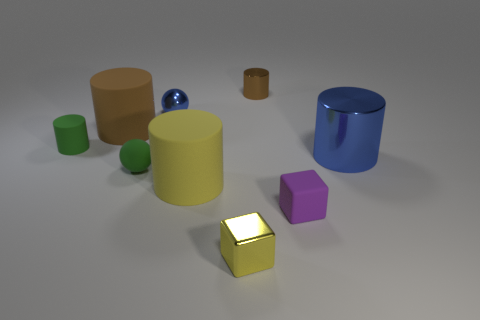What number of rubber things are tiny green spheres or things?
Your answer should be compact. 5. What color is the rubber cylinder to the right of the blue object behind the large brown thing?
Provide a succinct answer. Yellow. Is the material of the tiny yellow thing the same as the small cylinder that is on the right side of the tiny green sphere?
Keep it short and to the point. Yes. What is the color of the sphere that is on the left side of the small sphere that is on the right side of the green matte object in front of the tiny green matte cylinder?
Make the answer very short. Green. Is the number of tiny matte things greater than the number of small rubber spheres?
Offer a terse response. Yes. How many objects are behind the small purple rubber thing and left of the purple rubber block?
Provide a short and direct response. 6. There is a yellow object on the left side of the small yellow metal thing; what number of purple matte cubes are right of it?
Your answer should be compact. 1. Does the yellow object left of the tiny yellow block have the same size as the metal cylinder that is in front of the tiny brown metal object?
Keep it short and to the point. Yes. What number of blue matte cubes are there?
Keep it short and to the point. 0. What number of cubes have the same material as the large yellow cylinder?
Provide a short and direct response. 1. 